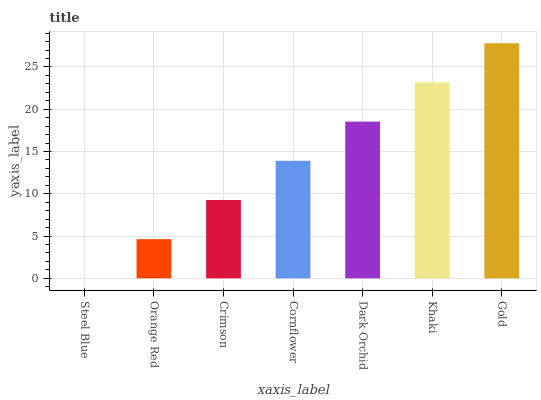Is Steel Blue the minimum?
Answer yes or no. Yes. Is Gold the maximum?
Answer yes or no. Yes. Is Orange Red the minimum?
Answer yes or no. No. Is Orange Red the maximum?
Answer yes or no. No. Is Orange Red greater than Steel Blue?
Answer yes or no. Yes. Is Steel Blue less than Orange Red?
Answer yes or no. Yes. Is Steel Blue greater than Orange Red?
Answer yes or no. No. Is Orange Red less than Steel Blue?
Answer yes or no. No. Is Cornflower the high median?
Answer yes or no. Yes. Is Cornflower the low median?
Answer yes or no. Yes. Is Gold the high median?
Answer yes or no. No. Is Khaki the low median?
Answer yes or no. No. 